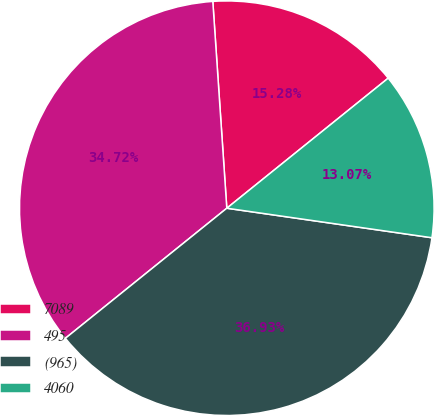Convert chart. <chart><loc_0><loc_0><loc_500><loc_500><pie_chart><fcel>7089<fcel>495<fcel>(965)<fcel>4060<nl><fcel>15.28%<fcel>34.72%<fcel>36.93%<fcel>13.07%<nl></chart> 